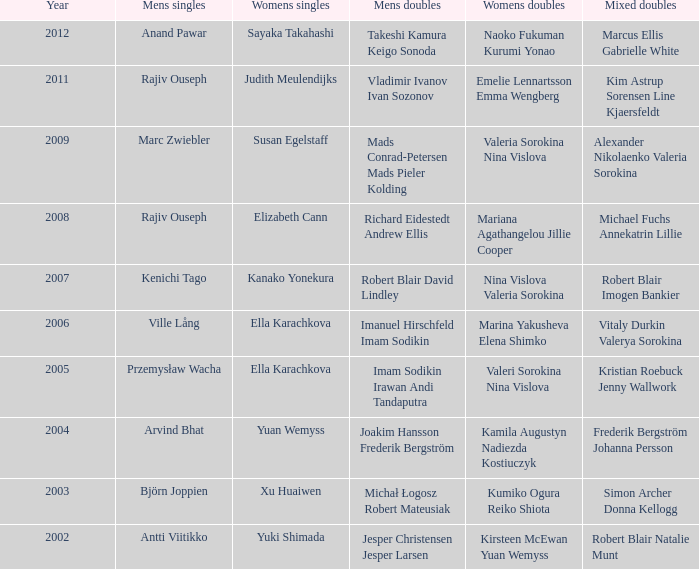Can you list the women's singles matches featuring imam sodikin irawan and andi tandaputra? Ella Karachkova. 